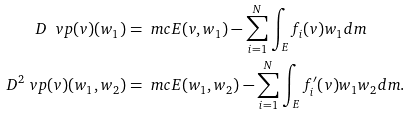<formula> <loc_0><loc_0><loc_500><loc_500>D \ v p ( v ) ( w _ { 1 } ) & = \ m c E ( v , w _ { 1 } ) - \sum _ { i = 1 } ^ { N } \int _ { E } f _ { i } ( v ) w _ { 1 } d m \\ D ^ { 2 } \ v p ( v ) ( w _ { 1 } , w _ { 2 } ) & = \ m c E ( w _ { 1 } , w _ { 2 } ) - \sum _ { i = 1 } ^ { N } \int _ { E } f _ { i } ^ { \prime } ( v ) w _ { 1 } w _ { 2 } d m .</formula> 